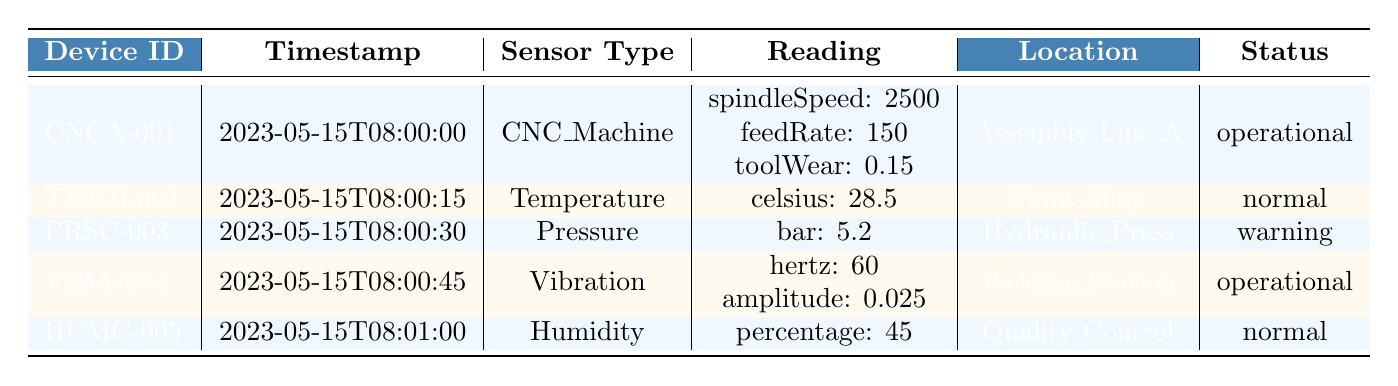What is the reading of the temperature sensor? The temperature sensor reading is specified as 28.5 degrees Celsius.
Answer: 28.5 degrees Celsius Which device has a status of "warning"? By checking the status column, the device "PRSC-003" has a status of "warning".
Answer: PRSC-003 What location is associated with the CNC Machine? The location for the CNC Machine is listed as "Assembly_Line_A".
Answer: Assembly_Line_A What is the spindle speed recorded by the CNC Machine? The spindle speed is part of the reading for the CNC Machine, which indicates it is 2500.
Answer: 2500 Is the humidity sensor operational? The status of the humidity sensor (HUMC-005) is "normal", indicating that it is operational.
Answer: Yes Which device has the highest reading for its respective sensor type? The CNC Machine has the highest spindle speed recorded at 2500, while other sensors represent different dimensions. Therefore, it has the highest specific reading.
Answer: CNC Machine What is the average bar reading across all devices? The bar reading is only recorded for the Pressure sensor, which has a value of 5.2. Therefore, the average is just 5.2 as there are no other readings to consider.
Answer: 5.2 Which devices were manufactured by Siemens and Bosch? The devices are TEMB-002 from Siemens and PRSC-003 from Bosch, as checked against the manufacturer column.
Answer: TEMB-002, PRSC-003 What is the interval between the timestamps of the readings? Looking at the timestamps, they are provided at 15-second intervals between each, so all readings are spaced 15 seconds apart.
Answer: 15 seconds If the humidity percentage decreases by 20%, what would the new percentage be? The current humidity percentage is 45. A decrease of 20% would be computed as 45 - (45 * 0.20) = 36.
Answer: 36 What is the average time of operation for all devices since their last maintenance? The last maintenance dates indicate that each device has been in operation since their respective last date. With different intervals, precise average calculation is not possible without specific time duration.
Answer: Varies by device 